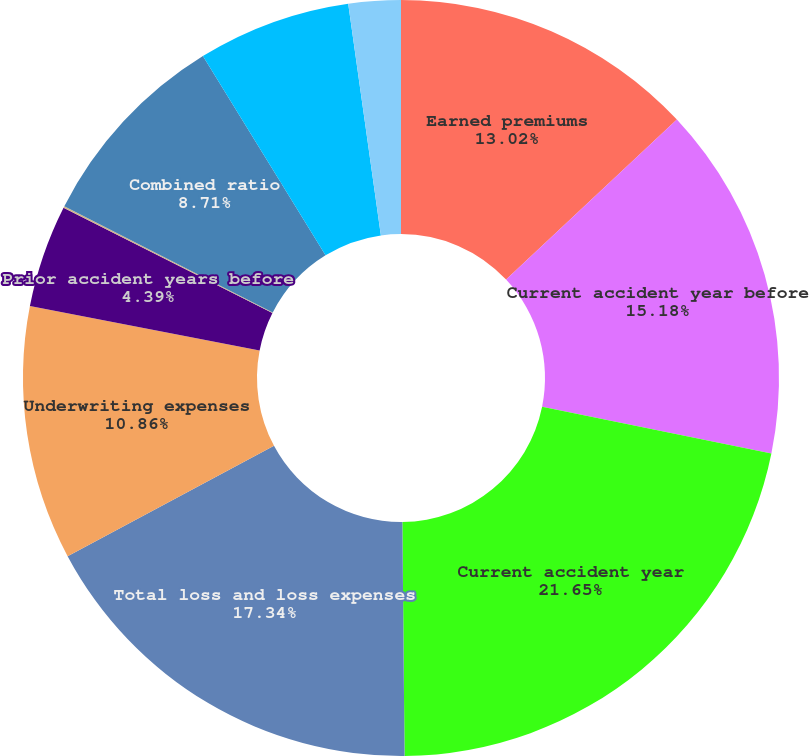<chart> <loc_0><loc_0><loc_500><loc_500><pie_chart><fcel>Earned premiums<fcel>Current accident year before<fcel>Current accident year<fcel>Total loss and loss expenses<fcel>Underwriting expenses<fcel>Prior accident years before<fcel>Prior accident years<fcel>Combined ratio<fcel>Contribution from catastrophe<fcel>Combined ratio before<nl><fcel>13.02%<fcel>15.18%<fcel>21.65%<fcel>17.34%<fcel>10.86%<fcel>4.39%<fcel>0.07%<fcel>8.71%<fcel>6.55%<fcel>2.23%<nl></chart> 